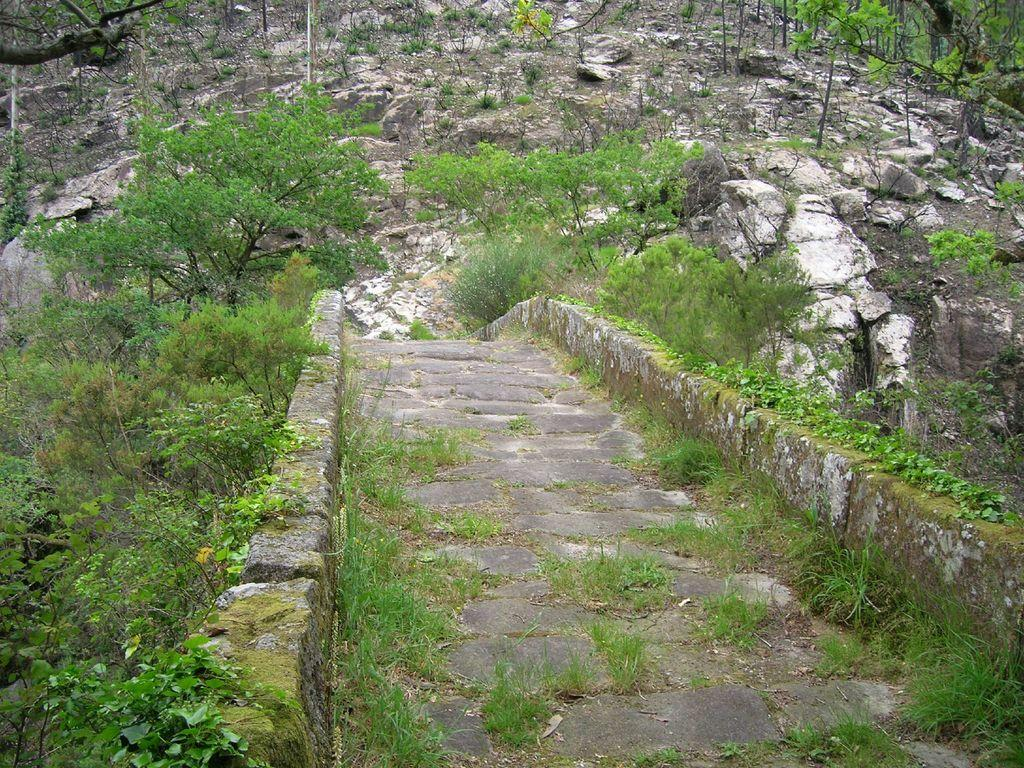What type of natural elements can be seen in the background of the image? There are rocks and plants in the background of the image. What type of vegetation is present in the image? There are trees in the image. What is the color of the grass in the image? Green grass is visible in the image. What architectural features can be seen on both sides of the image? There are walls on both the right and left sides of the image. What type of watch can be seen on the tree in the image? There is no watch present in the image; it features rocks, plants, trees, green grass, and walls. How does the steam escape from the rocks in the image? There is no steam present in the image; it only features rocks, plants, trees, green grass, and walls. 